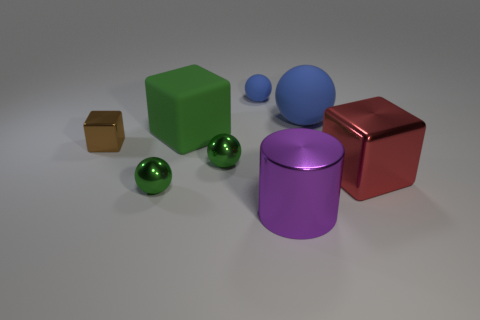Subtract 2 balls. How many balls are left? 2 Add 1 green shiny objects. How many objects exist? 9 Subtract all big rubber spheres. How many spheres are left? 3 Subtract 1 purple cylinders. How many objects are left? 7 Subtract all cylinders. How many objects are left? 7 Subtract all green cubes. Subtract all gray cylinders. How many cubes are left? 2 Subtract all blue spheres. How many red cubes are left? 1 Subtract all matte cubes. Subtract all small brown shiny things. How many objects are left? 6 Add 1 green spheres. How many green spheres are left? 3 Add 5 tiny green spheres. How many tiny green spheres exist? 7 